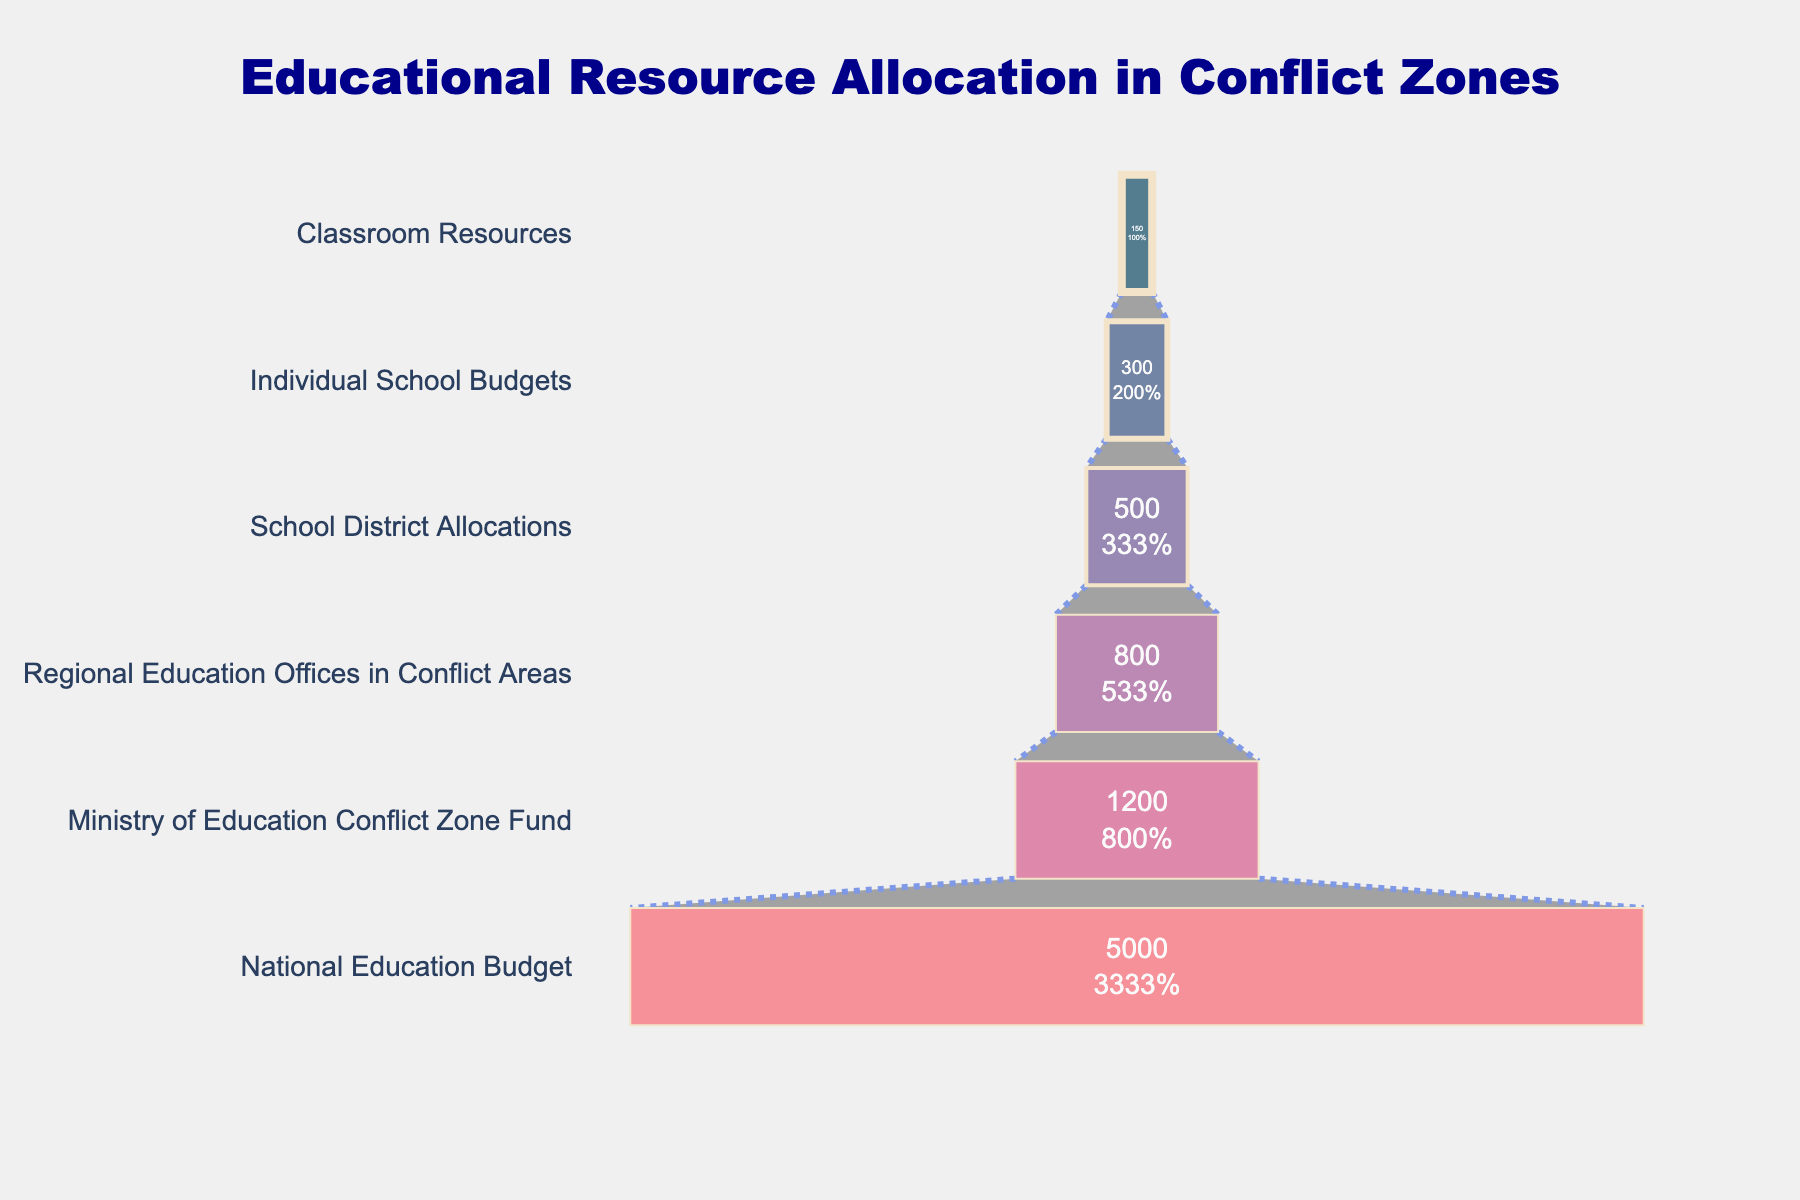What is the title of the funnel chart? The title of the funnel chart is positioned at the top center of the chart and is prominently displayed.
Answer: Educational Resource Allocation in Conflict Zones How many stages are there in the funnel chart? Each stage in the funnel represents a different level of allocation, visible as sections on the chart. By counting these sections, we can determine the total number.
Answer: Six Which stage receives the highest allocation? By looking at the widest part of the funnel located at the top, we can identify the stage with the largest allocation.
Answer: National Education Budget Which stage receives the lowest allocation? The smallest and last section at the bottom of the funnel represents the stage with the least allocation.
Answer: Classroom Resources What is the allocation value for Individual School Budgets? The chart provides the value directly inside the section for Individual School Budgets.
Answer: 300 million USD How much more funding does the National Education Budget receive compared to Classroom Resources? Subtract the allocation for Classroom Resources from the allocation for the National Education Budget.
Answer: 5000 - 150 = 4850 million USD What percentage of the initial allocation does the Classroom Resources receive? This percentage is labeled inside the Classroom Resources section.
Answer: 3% How does the allocation for Regional Education Offices in Conflict Areas compare to the Ministry of Education Conflict Zone Fund? Locate both sections and compare their allocation values.
Answer: 800 million USD is less than 1200 million USD What's the total allocation from the Regional Education Offices in Conflict Areas up to Classroom Resources? Sum the allocations for the stages from Regional Education Offices in Conflict Areas to Classroom Resources.
Answer: 800 + 500 + 300 + 150 = 1750 million USD What color represents the School District Allocations segment in the funnel chart? Identify the segment labeled School District Allocations and describe its color.
Answer: #a05195 (a shade of purplish-pink) 